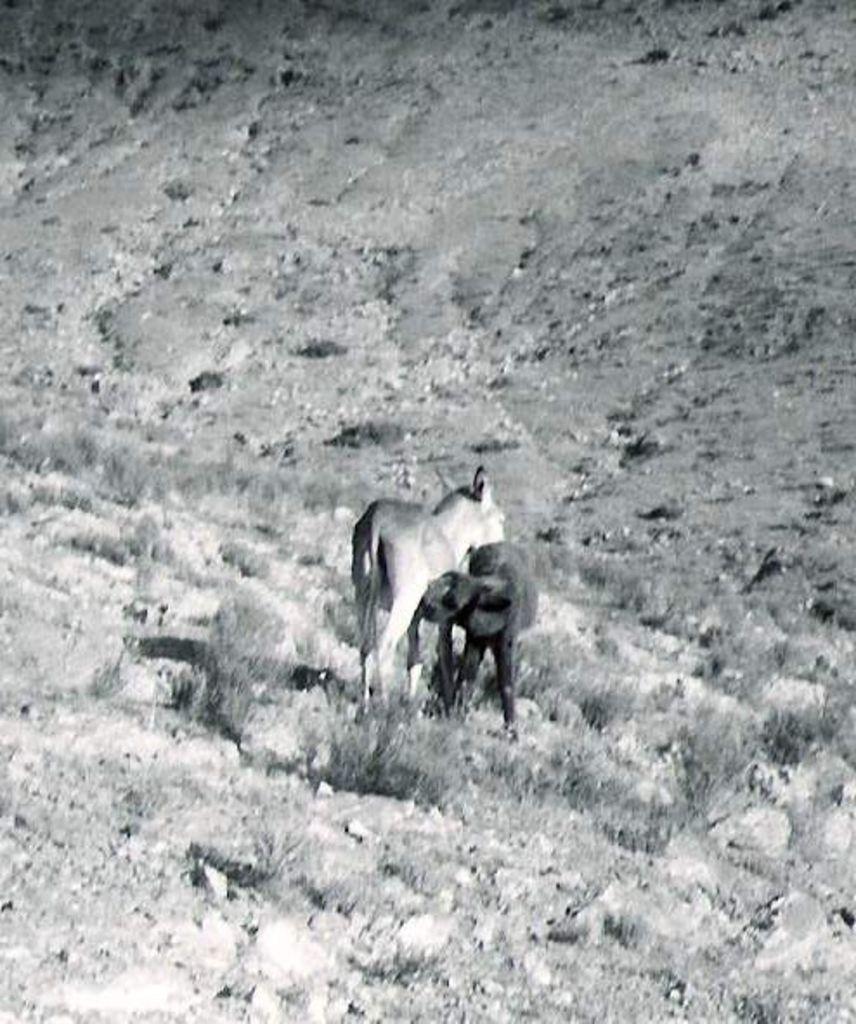Please provide a concise description of this image. In this image we can see two animals, also we can see the grass, and the picture is taken in black and white mode. 